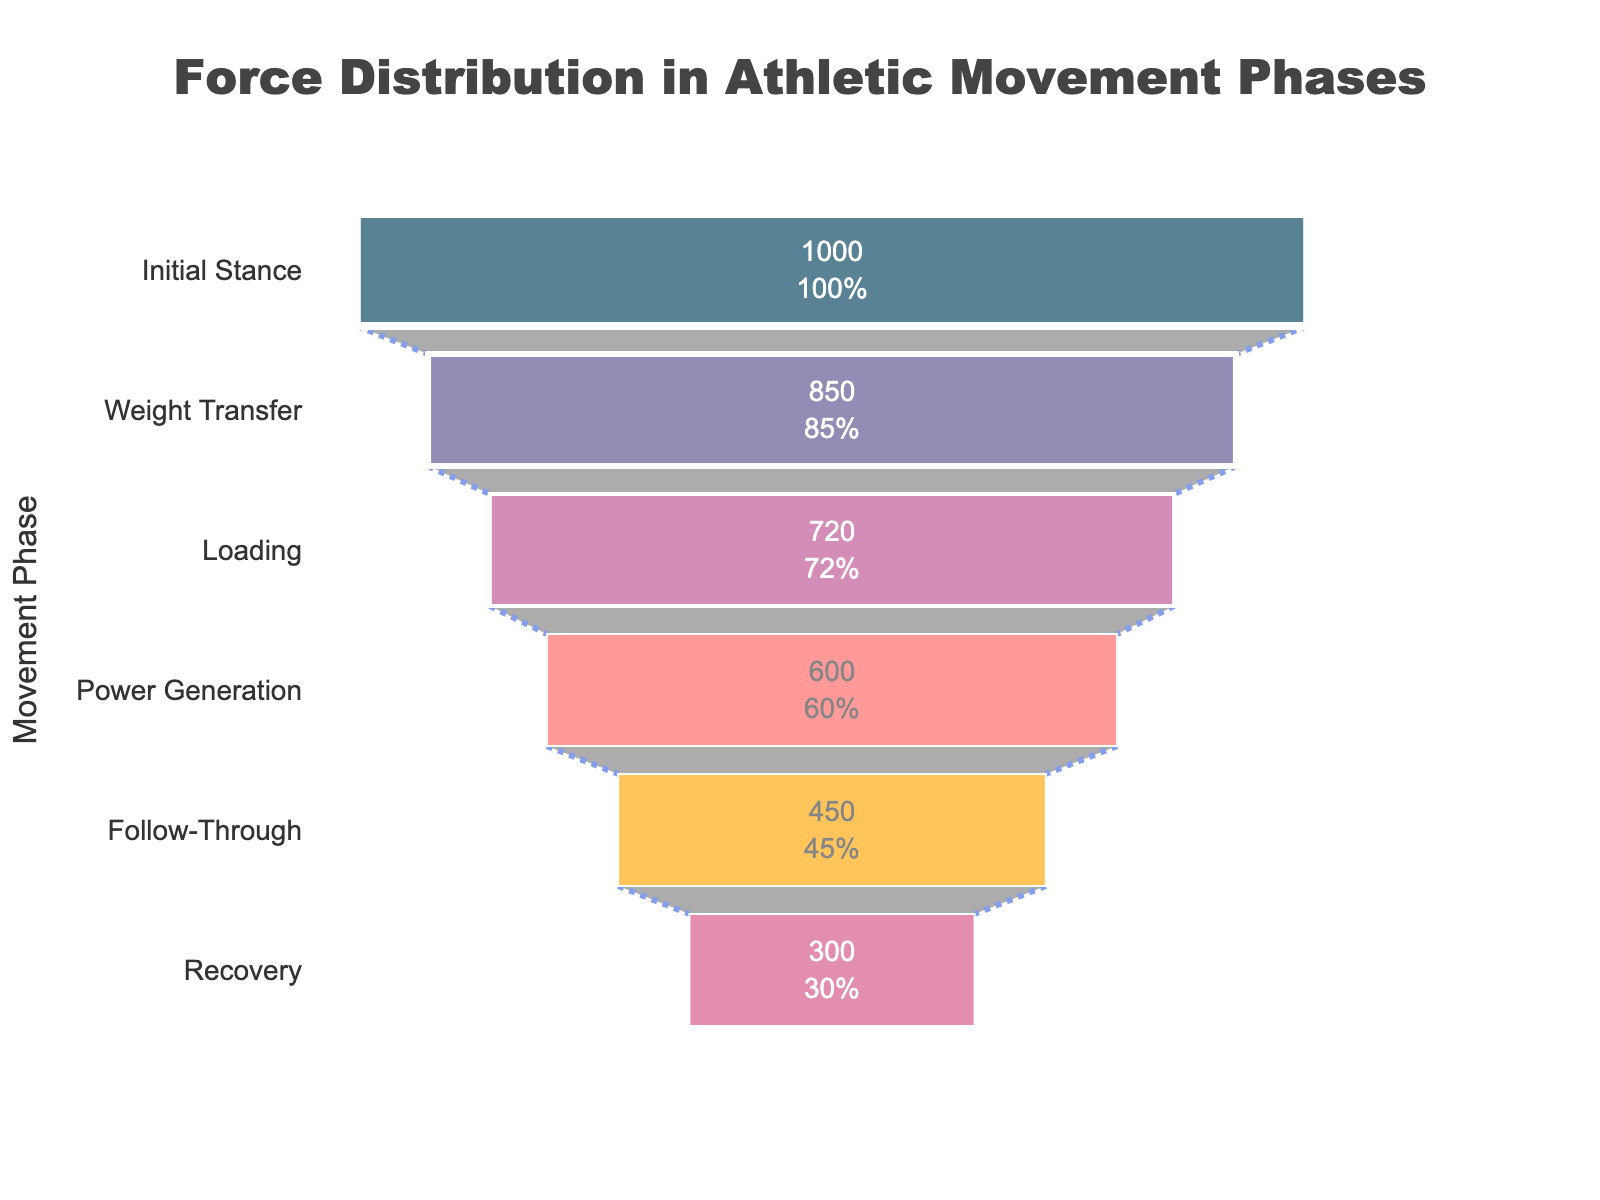What's the title of the plot? The title is prominently displayed at the top of the chart. It provides a summary of the data being visualized.
Answer: Force Distribution in Athletic Movement Phases How many movement phases are shown in the funnel chart? Count the number of distinct phases listed on the y-axis.
Answer: 6 Which phase has the highest force distribution? By looking at the values inside each segment of the funnel chart, identify the phase with the largest value.
Answer: Initial Stance What is the difference in force distribution between the Loading and Recovery phases? Subtract the force value of the Recovery phase from the Loading phase. Calculation: 720 N - 300 N = 420 N
Answer: 420 N In which phase do we see the largest drop in force distribution compared to the previous phase? Calculate the differences between consecutive phases and determine the largest drop. The largest drop is from Loading (720 N) to Power Generation (600 N). Calculation: 720 N - 600 N = 120 N
Answer: Loading to Power Generation What percentage of the initial force remains in the Follow-Through phase? The value in the Follow-Through phase is directly compared to the initial value. Calculation: (450 N / 1000 N) * 100% = 45%
Answer: 45% Which phase represents the transition to the least amount of force remaining from the initial value? Look for the phase with the lowest value in the funnel chart, which is Recovery with 300 N.
Answer: Recovery How much force is lost between the Initial Stance and Weight Transfer phases? Calculate the absolute difference between the force values for these two phases. Calculation: 1000 N - 850 N = 150 N
Answer: 150 N What is the combined force distribution for the Loading and Power Generation phases? Add the values of the Loading and Power Generation phases together. Calculation: 720 N + 600 N = 1320 N
Answer: 1320 N 